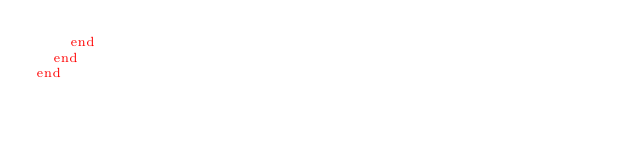Convert code to text. <code><loc_0><loc_0><loc_500><loc_500><_Crystal_>    end
  end
end
</code> 